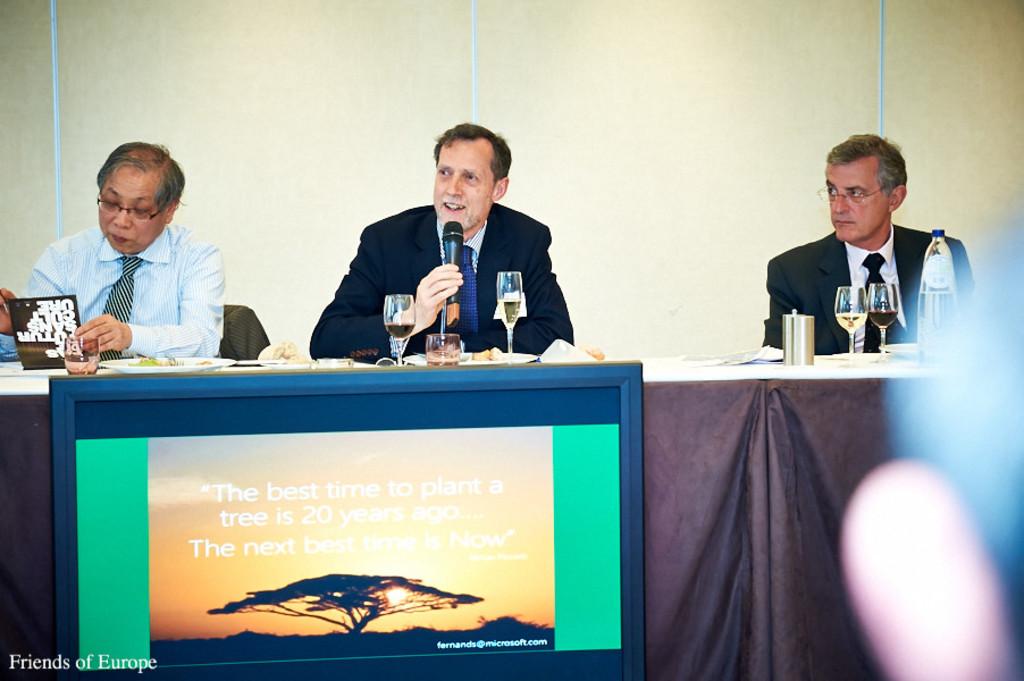What meeting is this?
Give a very brief answer. Friends of europe. When is the best time to plant a tree?
Provide a short and direct response. 20 years ago. 